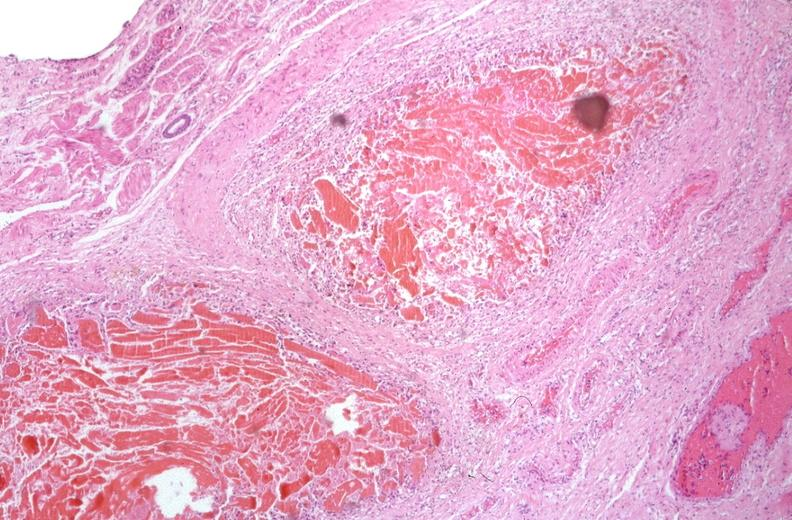why does this image show esophogus, varices portal hypertension?
Answer the question using a single word or phrase. Due to cirrhosis hcv 